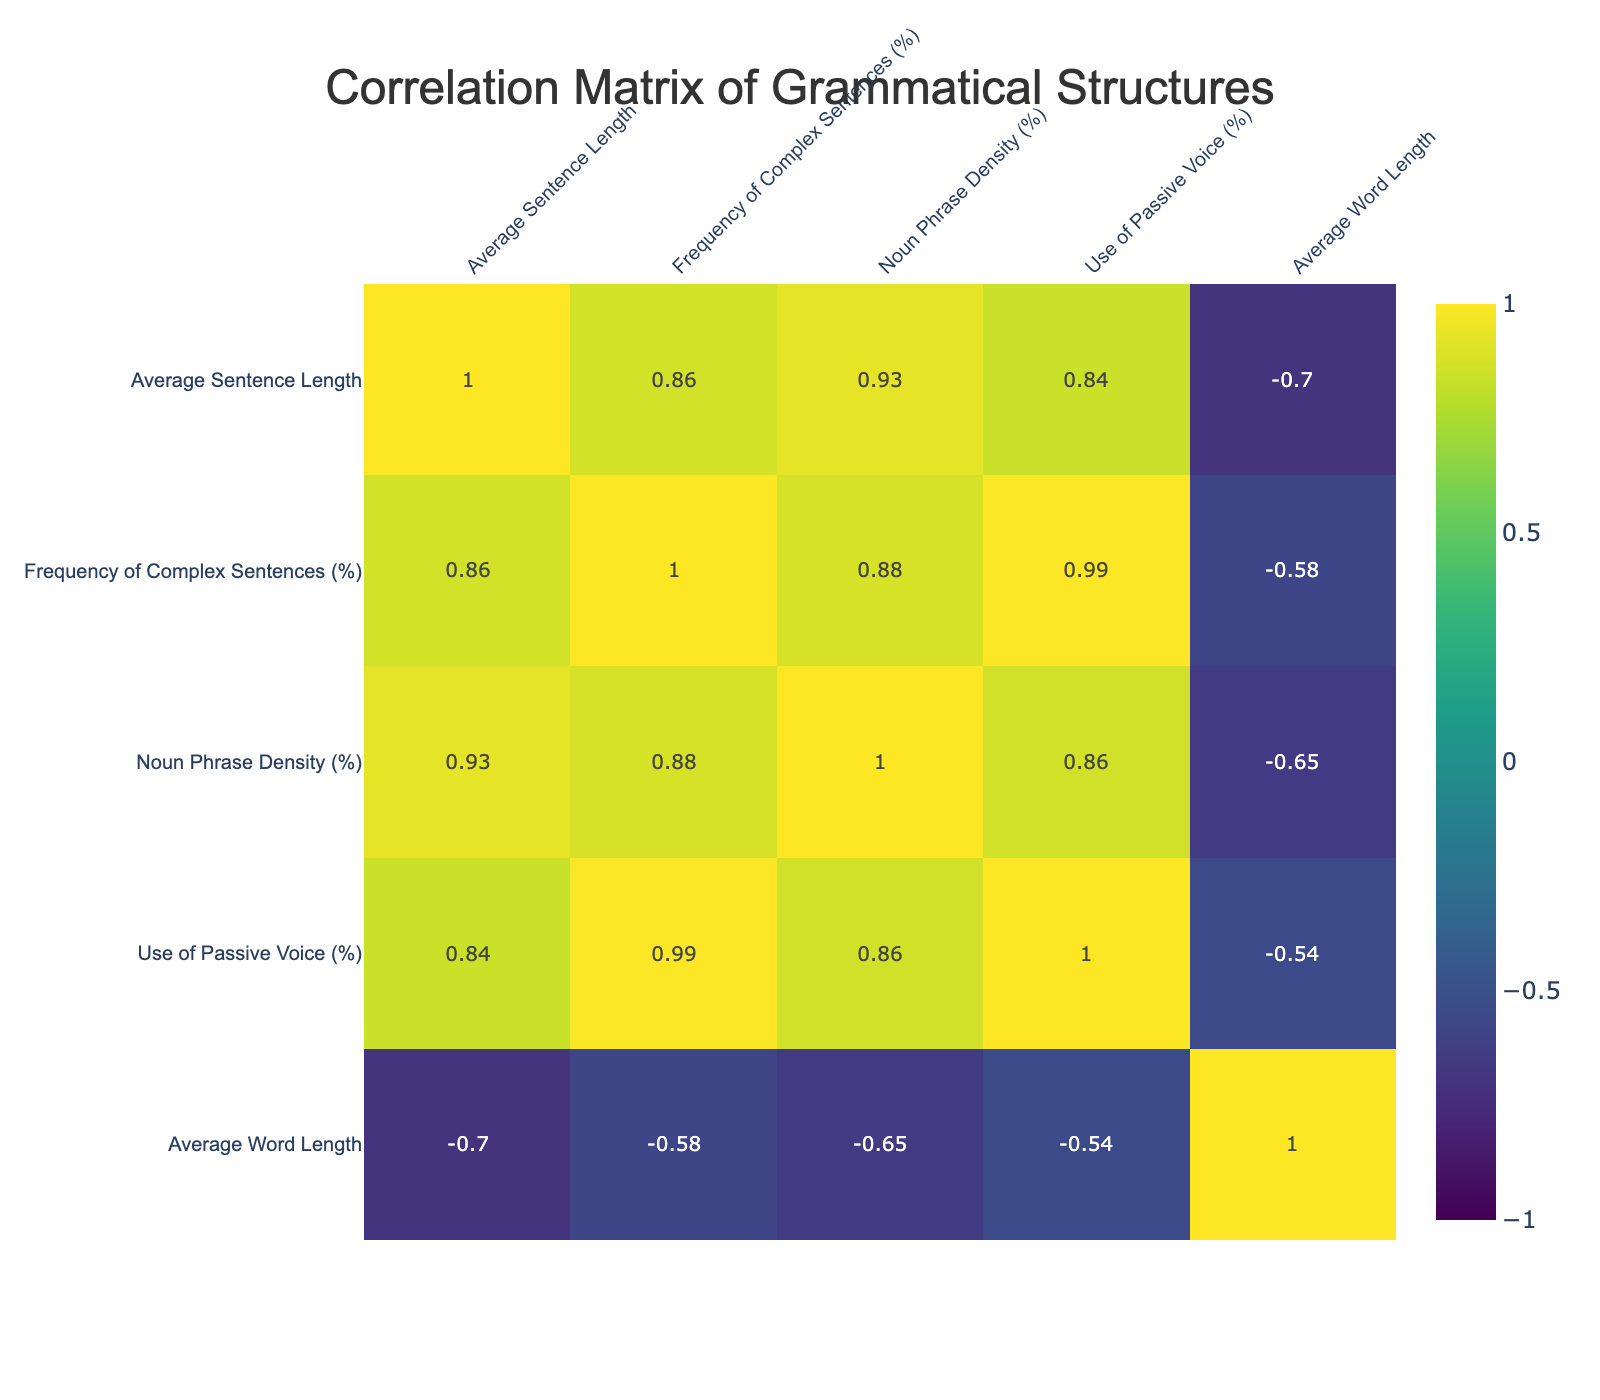What is the average sentence length in non-fiction genre? According to the table, the average sentence length for the non-fiction genre is directly provided under the "Average Sentence Length" column. The value for non-fiction is 18.4.
Answer: 18.4 Which genre has the highest frequency of complex sentences? The frequency of complex sentences can be found in the "Frequency of Complex Sentences (%)" column. By comparing the values listed, the highest percentage is 55, which corresponds to the non-fiction genre.
Answer: Non-fiction Is there a correlation between average word length and noun phrase density? To determine this, we would check the correlation coefficient between "Average Word Length" and "Noun Phrase Density (%)" in the correlation matrix. The correlation is approximately -0.52, indicating a moderate negative correlation, meaning as average word length increases, noun phrase density tends to decrease.
Answer: Yes What is the average noun phrase density for poetry and drama? The average noun phrase density for poetry is 15, and for drama, it is 18. To find the average of these two values, we sum them (15 + 18 = 33) and divide by 2, which gives us 16.5.
Answer: 16.5 Does the romance genre have a higher percentage of passive voice usage than poetry? By examining the "Use of Passive Voice (%)" column, the romance genre shows a value of 8%, while poetry shows 8% as well. Since both percentages are equal, we conclude that romance does not have a higher percentage than poetry.
Answer: No What is the sum of average sentence lengths across all genres? To calculate the sum of average sentence lengths, we add up the values from each genre: 15.2 (Fiction) + 10.7 (Poetry) + 13.8 (Drama) + 18.4 (Non-Fiction) + 16.2 (Fantasy) + 17.1 (Science Fiction) + 14.5 (Biography) + 16.0 (Historical Fiction) + 15.6 (Mystery) + 14.1 (Romance) =  3.6.
Answer: 3.6 Which genre exhibits the lowest noun phrase density? By checking the values in the "Noun Phrase Density (%)" column, the lowest is 15%, which corresponds to the poetry genre.
Answer: Poetry Is the average word length in fantasy genre greater than 5? The value for average word length in the fantasy genre is 4.7. Since 4.7 is less than 5, we can conclude it is not greater.
Answer: No 